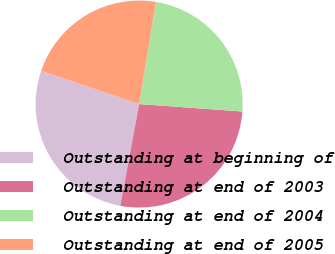Convert chart to OTSL. <chart><loc_0><loc_0><loc_500><loc_500><pie_chart><fcel>Outstanding at beginning of<fcel>Outstanding at end of 2003<fcel>Outstanding at end of 2004<fcel>Outstanding at end of 2005<nl><fcel>27.28%<fcel>26.77%<fcel>23.55%<fcel>22.4%<nl></chart> 